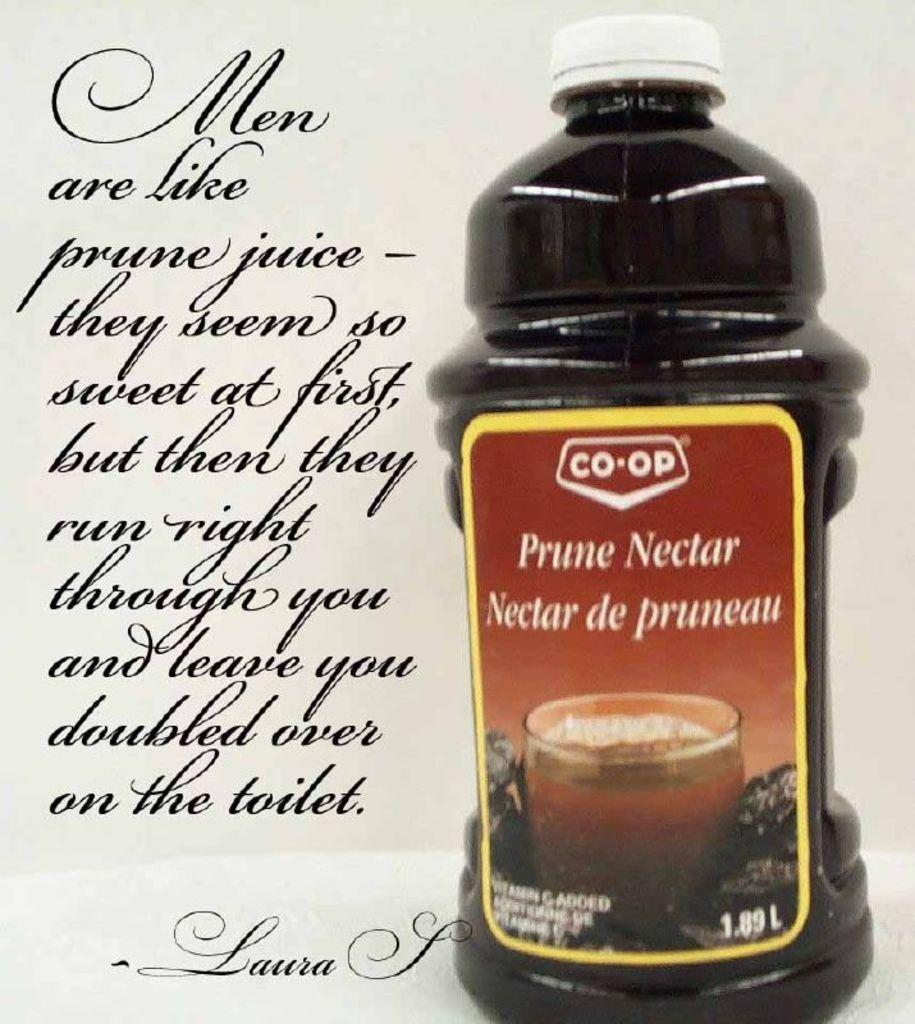What object can be seen in the image? There is a bottle in the image. What is inside the bottle? There is liquid inside the bottle. Is there any text or label on the bottle? Yes, there is something written on the left side of the bottle. Can you see any tubs or cables in the image? No, there are no tubs or cables present in the image. What type of air is visible in the image? There is no air visible in the image; it is a still image of a bottle. 